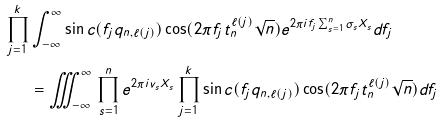<formula> <loc_0><loc_0><loc_500><loc_500>\prod _ { j = 1 } ^ { k } & \int _ { - \infty } ^ { \infty } \sin c ( f _ { j } q _ { n , \ell ( j ) } ) \cos ( 2 \pi f _ { j } t _ { n } ^ { \ell ( j ) } \sqrt { n } ) e ^ { 2 \pi i f _ { j } \sum _ { s = 1 } ^ { n } \sigma _ { s } X _ { s } } d f _ { j } \\ & = \iiint _ { - \infty } ^ { \infty } \, \prod _ { s = 1 } ^ { n } e ^ { 2 \pi i v _ { s } X _ { s } } \prod _ { j = 1 } ^ { k } \sin c ( f _ { j } q _ { n , \ell ( j ) } ) \cos ( 2 \pi f _ { j } t _ { n } ^ { \ell ( j ) } \sqrt { n } ) d f _ { j }</formula> 